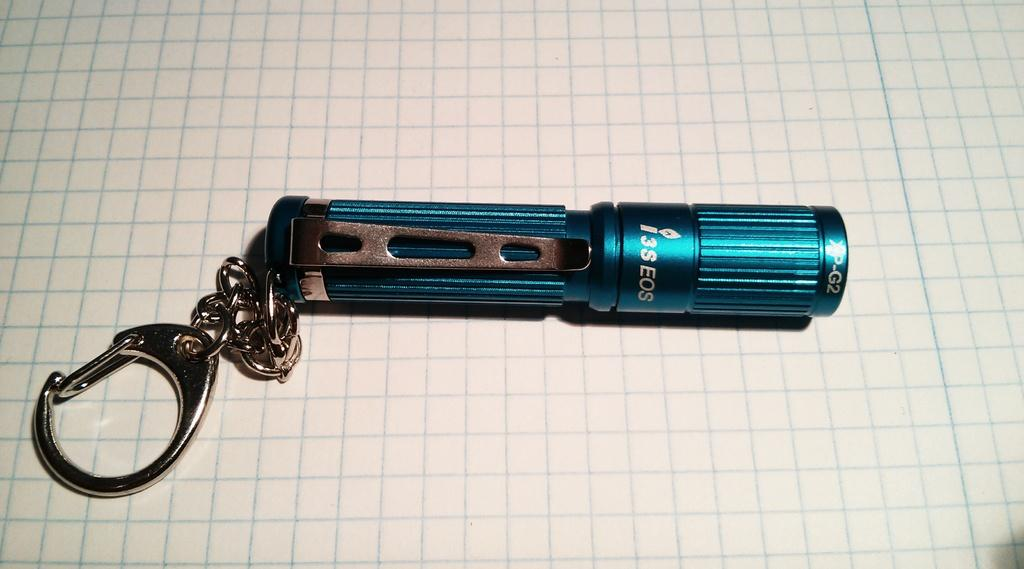What color is the key-chain in the image? The key-chain in the image is blue. What is the key-chain placed on in the image? The key-chain is on a white surface. What type of stamp is being used at the meeting in the image? There is no stamp or meeting present in the image; it only features a blue key-chain on a white surface. 